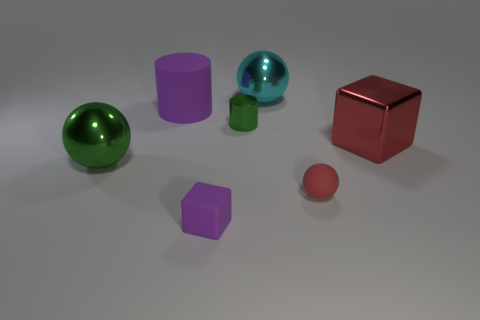Subtract all red rubber balls. How many balls are left? 2 Add 1 large green metal balls. How many objects exist? 8 Subtract all red blocks. How many blocks are left? 1 Subtract 1 red balls. How many objects are left? 6 Subtract all spheres. How many objects are left? 4 Subtract all cyan cylinders. Subtract all purple blocks. How many cylinders are left? 2 Subtract all large green metallic spheres. Subtract all matte balls. How many objects are left? 5 Add 4 red rubber objects. How many red rubber objects are left? 5 Add 1 small red matte objects. How many small red matte objects exist? 2 